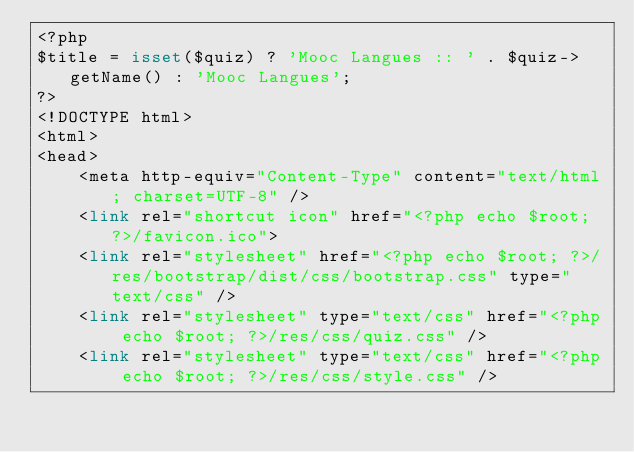Convert code to text. <code><loc_0><loc_0><loc_500><loc_500><_PHP_><?php
$title = isset($quiz) ? 'Mooc Langues :: ' . $quiz->getName() : 'Mooc Langues';
?>
<!DOCTYPE html>
<html>
<head>
    <meta http-equiv="Content-Type" content="text/html; charset=UTF-8" />
    <link rel="shortcut icon" href="<?php echo $root; ?>/favicon.ico">
    <link rel="stylesheet" href="<?php echo $root; ?>/res/bootstrap/dist/css/bootstrap.css" type="text/css" />
    <link rel="stylesheet" type="text/css" href="<?php echo $root; ?>/res/css/quiz.css" />
    <link rel="stylesheet" type="text/css" href="<?php echo $root; ?>/res/css/style.css" /></code> 